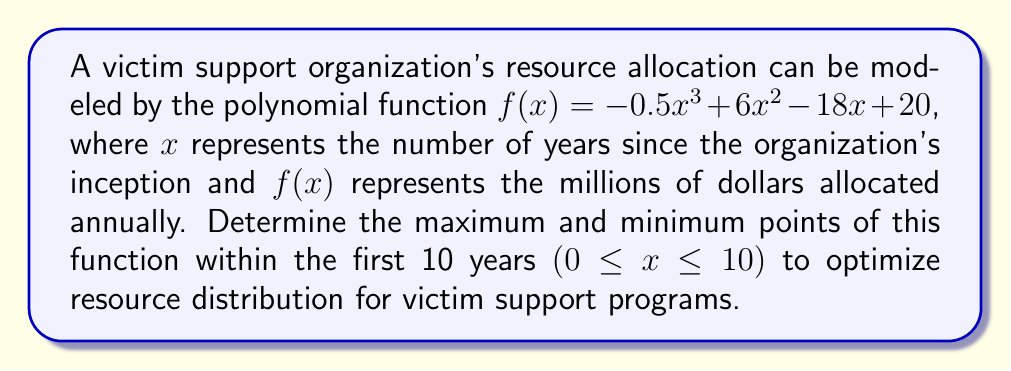What is the answer to this math problem? To find the maximum and minimum points, we need to follow these steps:

1) Find the derivative of the function:
   $f'(x) = -1.5x^2 + 12x - 18$

2) Set the derivative equal to zero and solve for x:
   $-1.5x^2 + 12x - 18 = 0$
   $-3x^2 + 24x - 36 = 0$
   $-3(x^2 - 8x + 12) = 0$
   $-3(x - 6)(x - 2) = 0$
   $x = 6$ or $x = 2$

3) Calculate the second derivative:
   $f''(x) = -3x + 12$

4) Evaluate the second derivative at each critical point:
   At $x = 2$: $f''(2) = -3(2) + 12 = 6 > 0$, so this is a local minimum
   At $x = 6$: $f''(6) = -3(6) + 12 = -6 < 0$, so this is a local maximum

5) Calculate the y-values for these points:
   At $x = 2$: $f(2) = -0.5(2)^3 + 6(2)^2 - 18(2) + 20 = 8$ million
   At $x = 6$: $f(6) = -0.5(6)^3 + 6(6)^2 - 18(6) + 20 = 32$ million

6) Check the endpoints of the interval [0, 10]:
   At $x = 0$: $f(0) = 20$ million
   At $x = 10$: $f(10) = -0.5(10)^3 + 6(10)^2 - 18(10) + 20 = -230$ million

Therefore, within the given interval, the maximum point is (6, 32) and the minimum point is (2, 8).
Answer: Maximum: (6, 32), Minimum: (2, 8) 